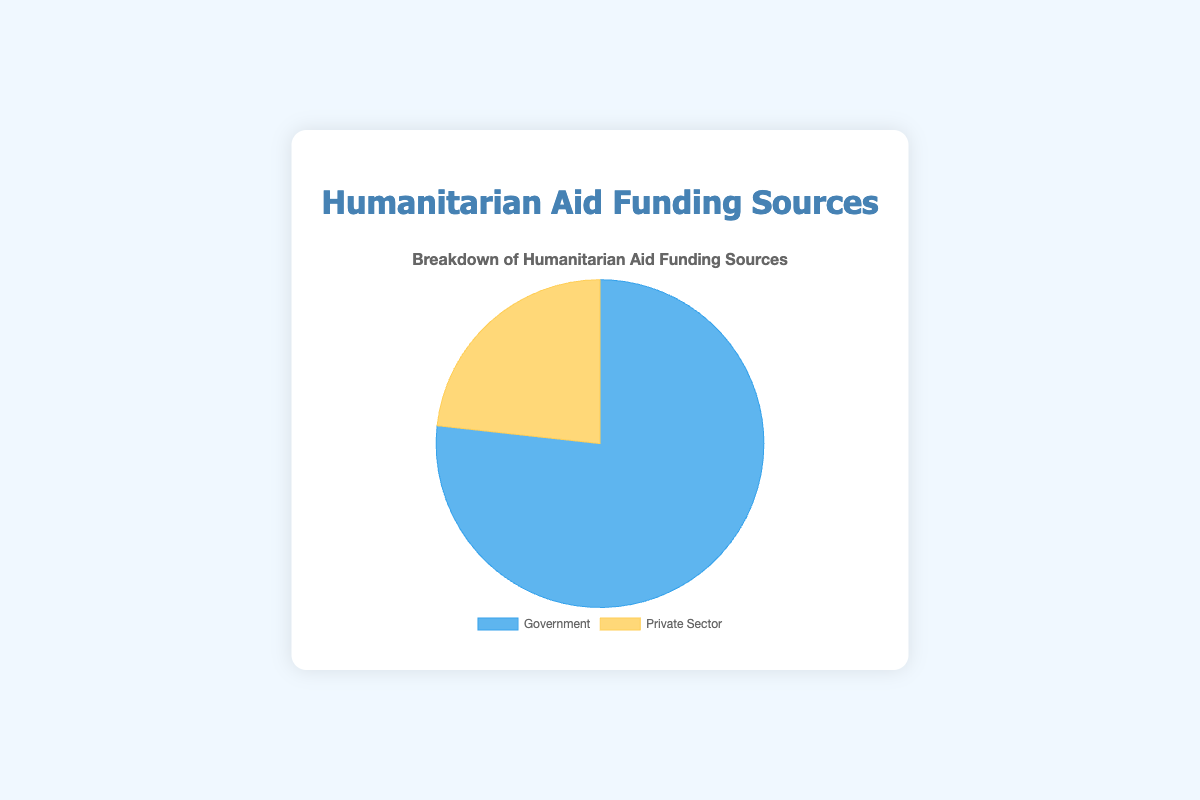What is the total amount of humanitarian aid funding coming from the government sources? To find the total amount of humanitarian aid funding from government sources, sum up the values from each country: 6,000,000,000 (US) + 4,500,000,000 (EU) + 2,000,000,000 (UK) + 3,000,000,000 (Germany) + 1,500,000,000 (Canada) + 1,800,000,000 (Japan) + 1,000,000,000 (Australia). This results in a total of 19,800,000,000
Answer: 19,800,000,000 What percentage of the total humanitarian aid funding comes from the private sector? To find this percentage, calculate the total funding from the private sector and the government. Then divide the private sector total by the combined total and multiply by 100: Private sector total = 6,000,000,000, Government total = 19,800,000,000, Combined total = 25,800,000,000. So, (6,000,000,000 / 25,800,000,000) * 100 is approximately 23.26%
Answer: 23.26% Which sector contributes more to humanitarian aid funding, and by how much? First, find the contributions from both sectors. Government: 19,800,000,000, Private Sector: 6,000,000,000. Subtract the private sector value from the government value: 19,800,000,000 - 6,000,000,000 = 13,800,000,000. Hence, the government sector contributes more by 13,800,000,000
Answer: Government, by 13,800,000,000 How do the contributions from government and private sectors compare visually in the chart? The pie chart visually shows the government sector as a larger portion compared to the private sector. The government slice is roughly three-fourths whereas the private sector slice is about one-fourth of the pie, indicative of the larger funding from the government.
Answer: Government sector is larger If the government funding was 10 billion less, would it still be more than private sector funding? Subtract 10 billion from the current government funding: 19,800,000,000 - 10,000,000,000 = 9,800,000,000. Since the private sector funding is 6,000,000,000, the government funding (9,800,000,000) would still be more than the private sector: 9,800,000,000 > 6,000,000,000
Answer: Yes What is the ratio of government funding to private sector funding? To find the ratio, divide the government total by the private sector total: 19,800,000,000 / 6,000,000,000 = 3.3. This means the government funding is 3.3 times more than the private sector funding
Answer: 3.3:1 If combined funding increased by 20%, how much would the new total be? First, find the combined current funding: 25,800,000,000. Increase this by 20%: 0.20 * 25,800,000,000 = 5,160,000,000. Add this to the current total: 25,800,000,000 + 5,160,000,000 = 30,960,000,000
Answer: 30,960,000,000 How much more funding does UNICEF receive compared to World Vision? From the private sector data, UNICEF receives 1,000,000,000 while World Vision receives 500,000,000. Subtract the two values: 1,000,000,000 - 500,000,000 = 500,000,000
Answer: 500,000,000 